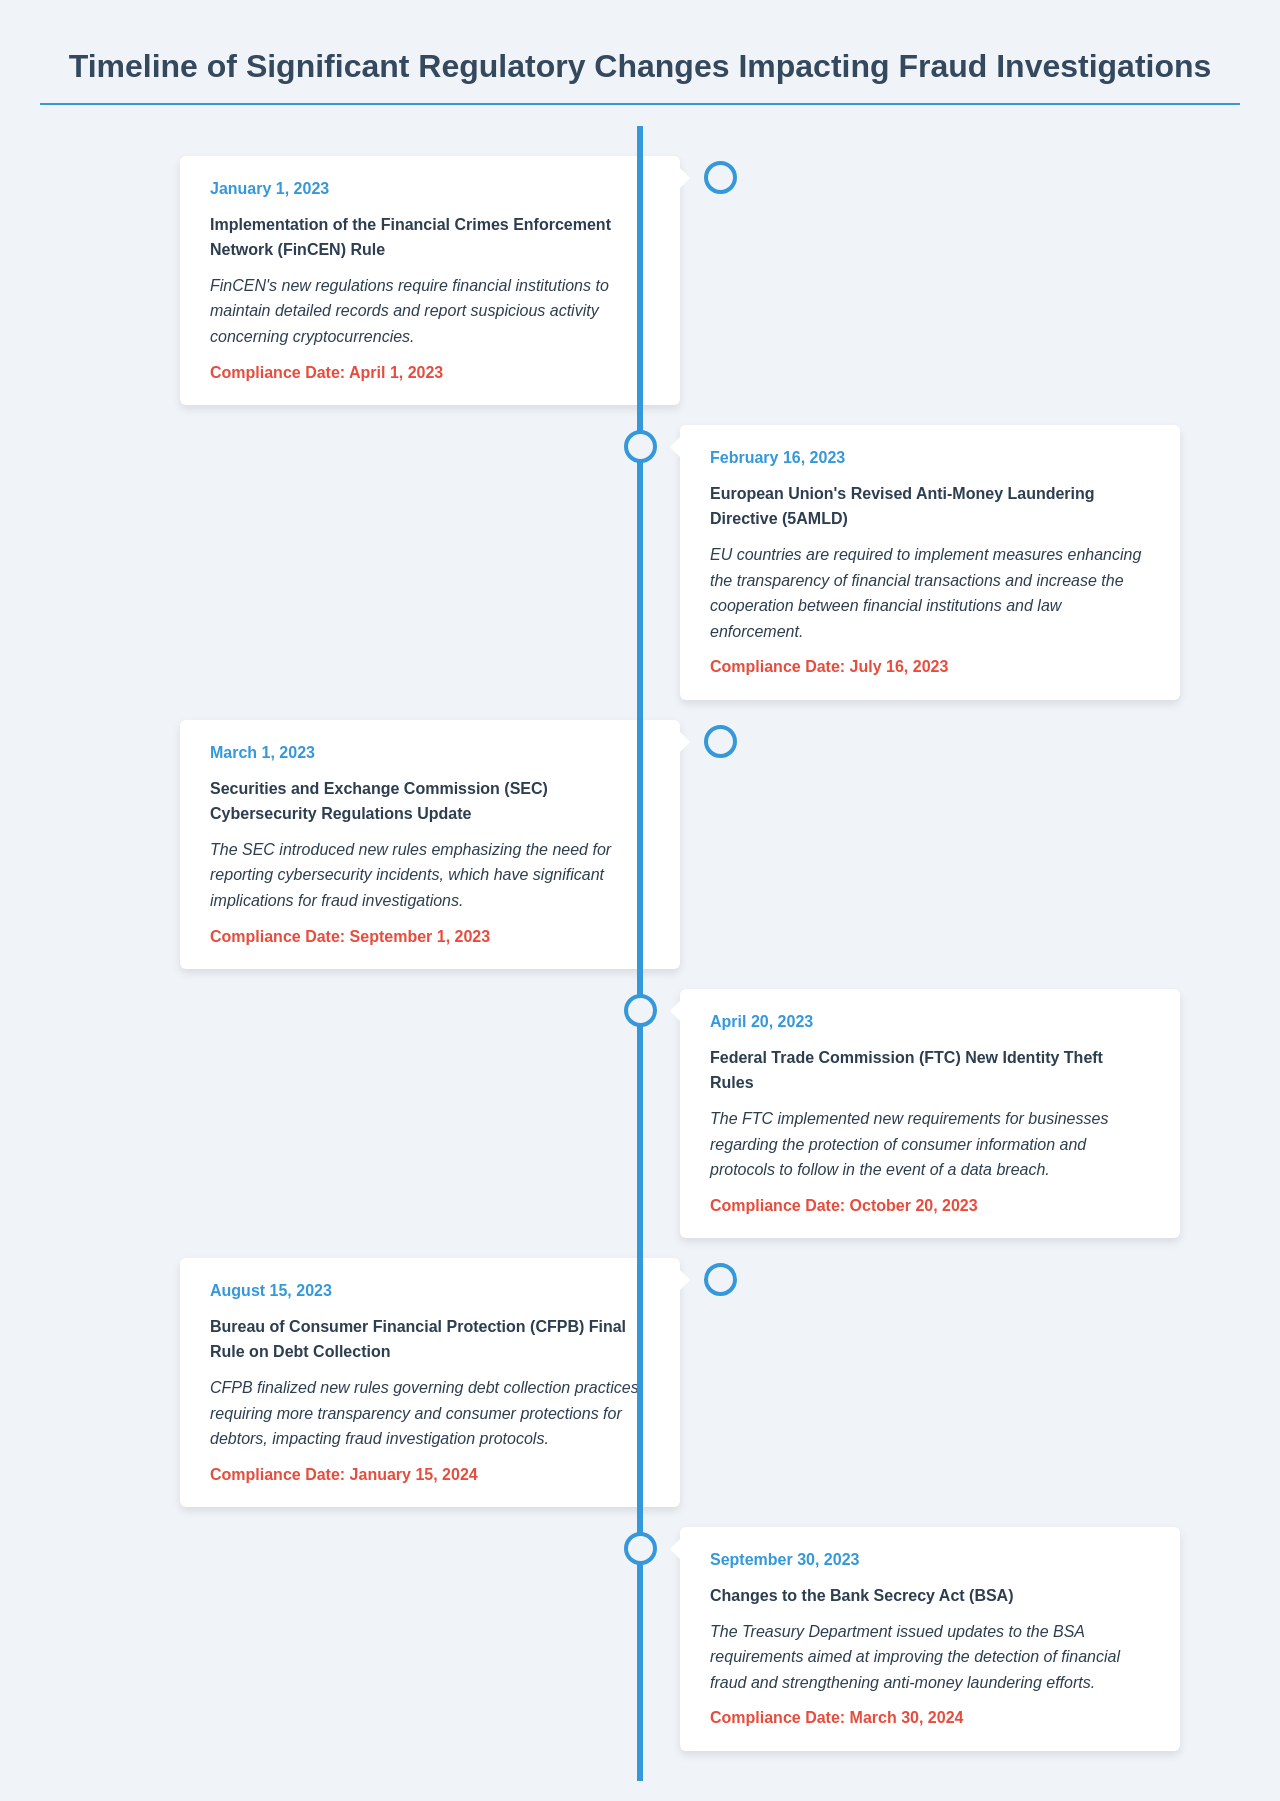What is the date of the FinCEN Rule implementation? The FinCEN Rule was implemented on January 1, 2023.
Answer: January 1, 2023 What rules did the FTC implement on April 20, 2023? The FTC implemented new Identity Theft Rules on April 20, 2023.
Answer: Identity Theft Rules What is the compliance date of the CFPB's Final Rule on Debt Collection? The compliance date for the CFPB's Final Rule on Debt Collection is January 15, 2024.
Answer: January 15, 2024 How many significant regulatory changes are highlighted in the document? The document highlights six significant regulatory changes impacting fraud investigations.
Answer: Six What is the primary focus of the changes to the Bank Secrecy Act? The changes to the BSA focus on improving the detection of financial fraud.
Answer: Financial fraud Which regulatory body updated its cybersecurity regulations in March 2023? The Securities and Exchange Commission (SEC) updated its cybersecurity regulations.
Answer: SEC 